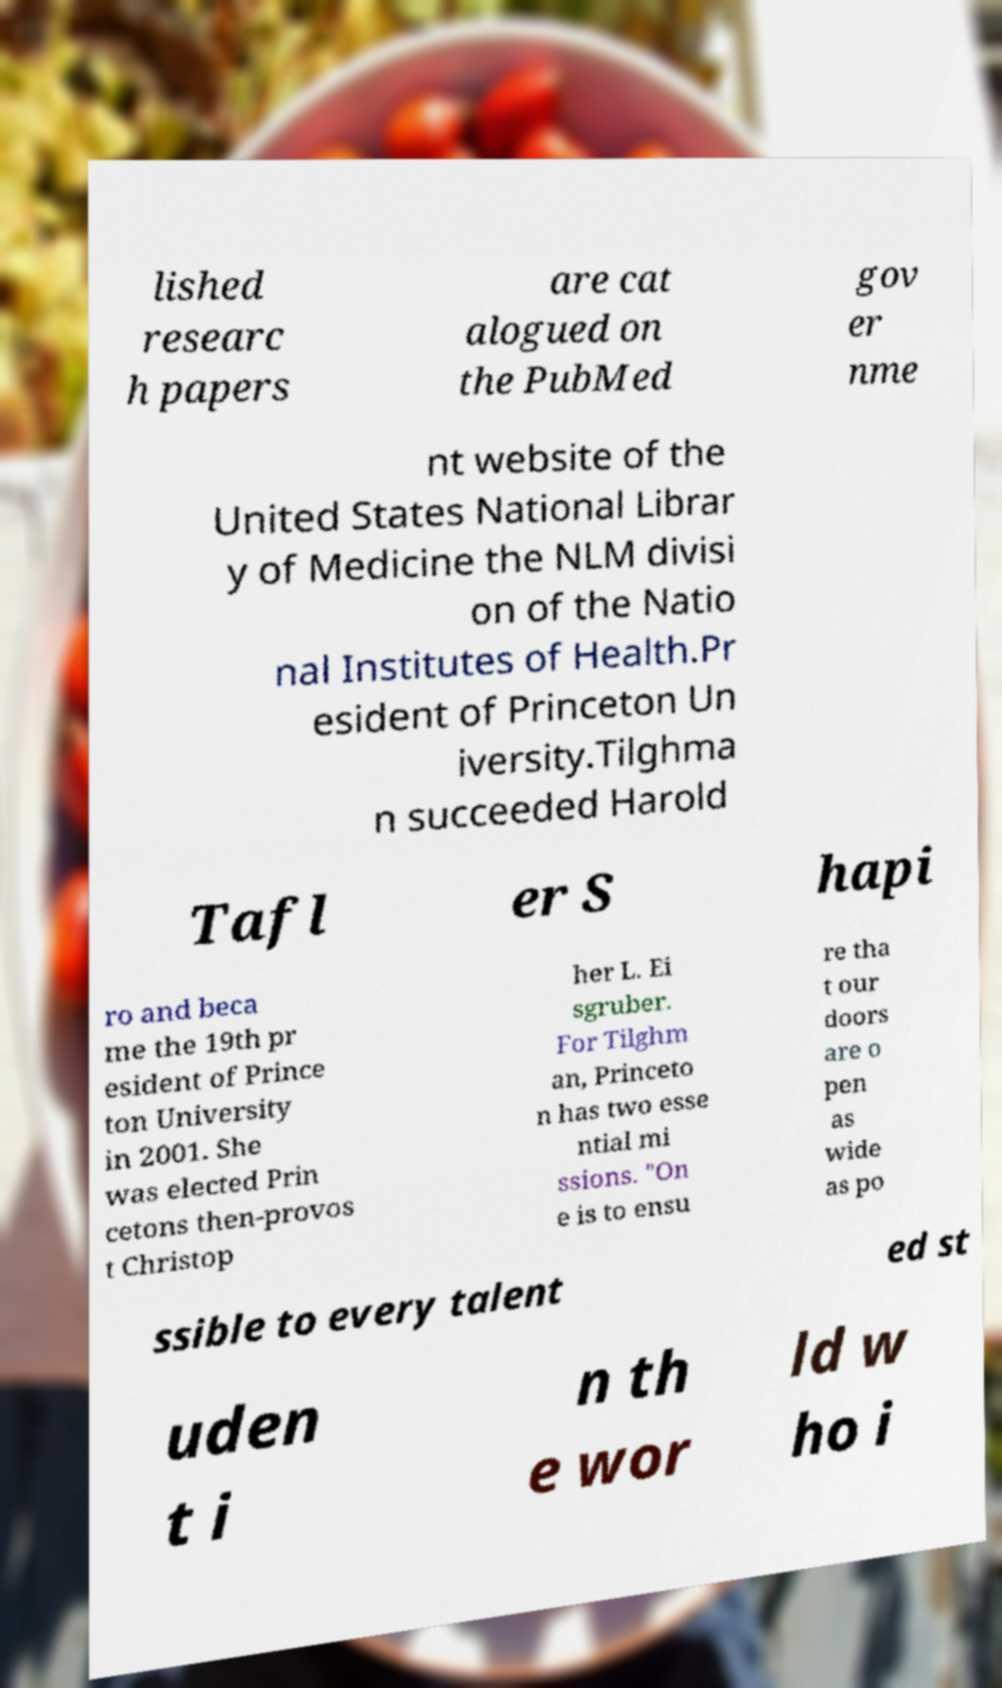Please identify and transcribe the text found in this image. lished researc h papers are cat alogued on the PubMed gov er nme nt website of the United States National Librar y of Medicine the NLM divisi on of the Natio nal Institutes of Health.Pr esident of Princeton Un iversity.Tilghma n succeeded Harold Tafl er S hapi ro and beca me the 19th pr esident of Prince ton University in 2001. She was elected Prin cetons then-provos t Christop her L. Ei sgruber. For Tilghm an, Princeto n has two esse ntial mi ssions. "On e is to ensu re tha t our doors are o pen as wide as po ssible to every talent ed st uden t i n th e wor ld w ho i 